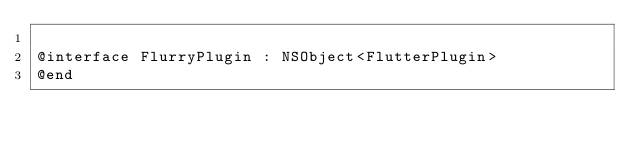<code> <loc_0><loc_0><loc_500><loc_500><_C_>
@interface FlurryPlugin : NSObject<FlutterPlugin>
@end
</code> 